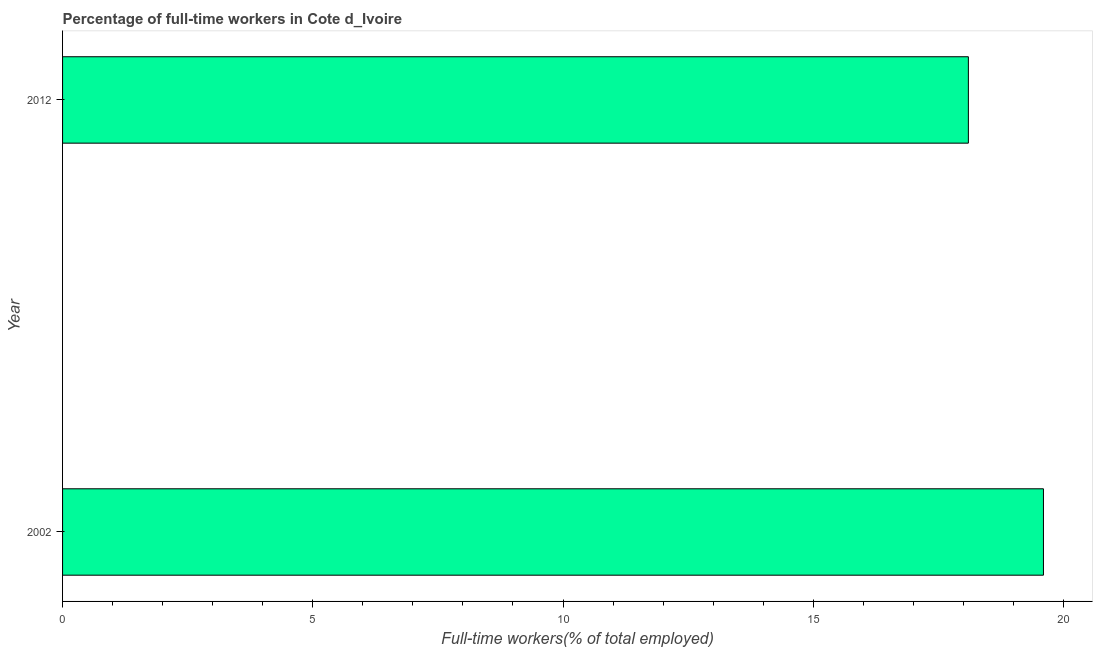Does the graph contain any zero values?
Keep it short and to the point. No. What is the title of the graph?
Your answer should be compact. Percentage of full-time workers in Cote d_Ivoire. What is the label or title of the X-axis?
Give a very brief answer. Full-time workers(% of total employed). What is the label or title of the Y-axis?
Ensure brevity in your answer.  Year. What is the percentage of full-time workers in 2012?
Your answer should be compact. 18.1. Across all years, what is the maximum percentage of full-time workers?
Ensure brevity in your answer.  19.6. Across all years, what is the minimum percentage of full-time workers?
Your response must be concise. 18.1. In which year was the percentage of full-time workers maximum?
Offer a very short reply. 2002. What is the sum of the percentage of full-time workers?
Keep it short and to the point. 37.7. What is the average percentage of full-time workers per year?
Give a very brief answer. 18.85. What is the median percentage of full-time workers?
Provide a short and direct response. 18.85. What is the ratio of the percentage of full-time workers in 2002 to that in 2012?
Make the answer very short. 1.08. In how many years, is the percentage of full-time workers greater than the average percentage of full-time workers taken over all years?
Ensure brevity in your answer.  1. How many bars are there?
Provide a succinct answer. 2. Are all the bars in the graph horizontal?
Provide a succinct answer. Yes. How many years are there in the graph?
Your answer should be compact. 2. What is the difference between two consecutive major ticks on the X-axis?
Offer a very short reply. 5. Are the values on the major ticks of X-axis written in scientific E-notation?
Your answer should be compact. No. What is the Full-time workers(% of total employed) of 2002?
Offer a very short reply. 19.6. What is the Full-time workers(% of total employed) in 2012?
Offer a very short reply. 18.1. What is the ratio of the Full-time workers(% of total employed) in 2002 to that in 2012?
Give a very brief answer. 1.08. 